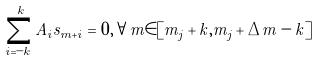Convert formula to latex. <formula><loc_0><loc_0><loc_500><loc_500>\sum _ { i = - k } ^ { k } A _ { i } s _ { m + i } = 0 , \forall m \in [ m _ { j } + k , m _ { j } + \Delta m - k ]</formula> 